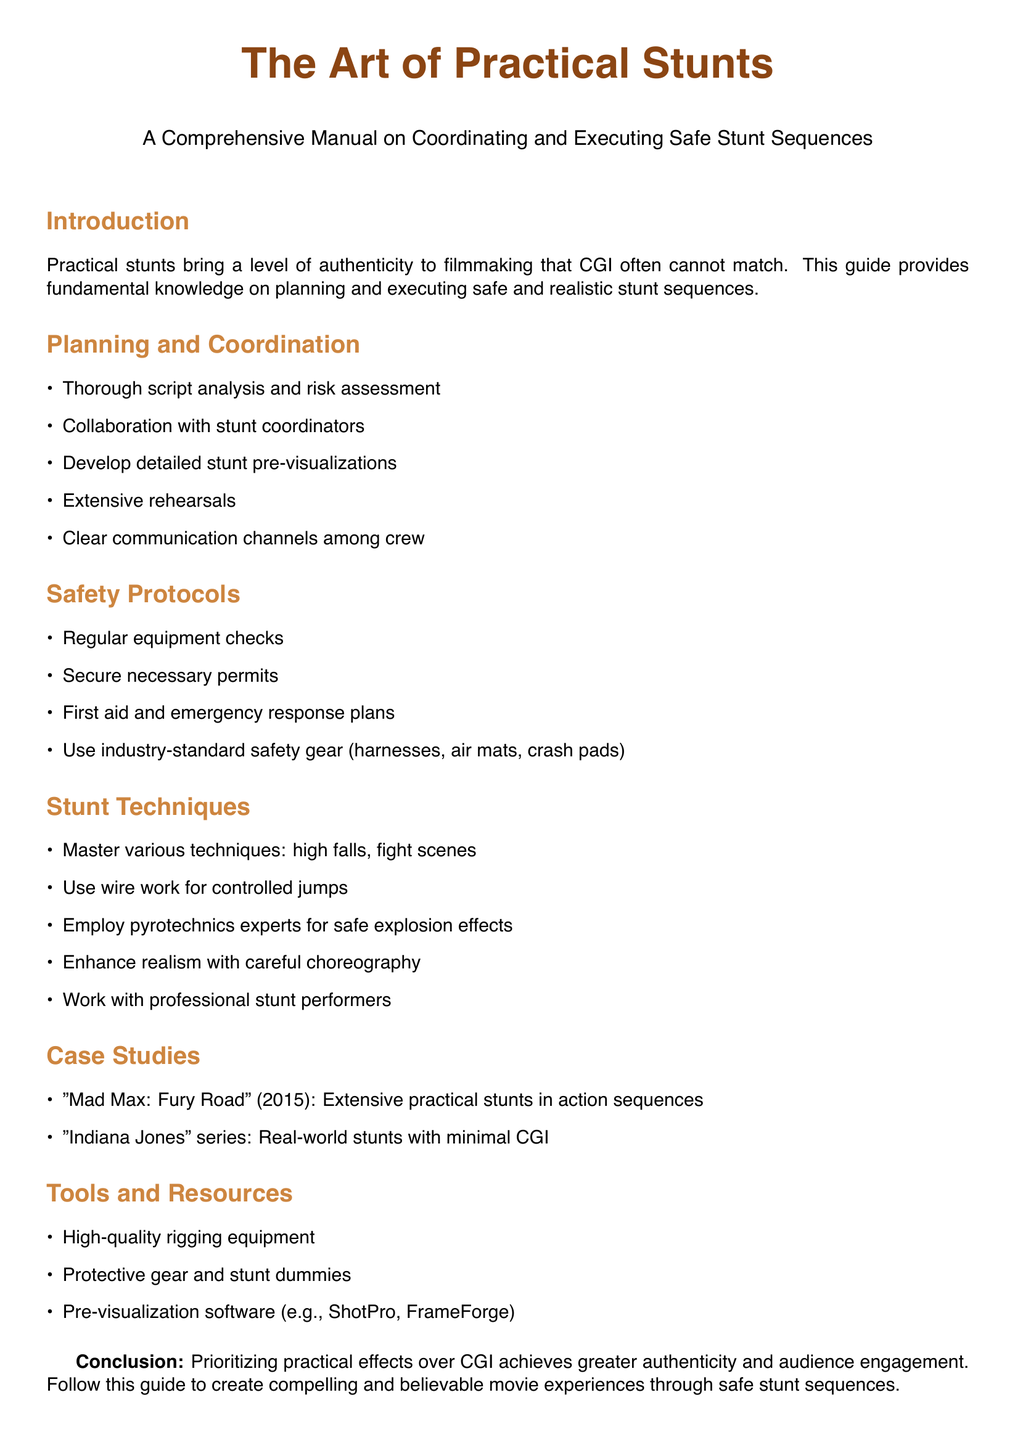what is the main focus of the guide? The guide focuses on practical stunts as a means of achieving authenticity in filmmaking.
Answer: authenticity what are the two notable case studies mentioned? The guide lists "Mad Max: Fury Road" and the "Indiana Jones" series as case studies.
Answer: "Mad Max: Fury Road" and "Indiana Jones" what safety gear is recommended in the guide? The guide recommends industry-standard safety gear including harnesses, air mats, and crash pads.
Answer: harnesses, air mats, crash pads what is the purpose of pre-visualizations in stunt planning? Pre-visualizations help in detailing and planning stunt sequences before execution.
Answer: planning stunt sequences how many main sections are in the guide? The document has five main sections including Introduction and Conclusion.
Answer: five which software is mentioned for pre-visualization? The guide mentions ShotPro and FrameForge as pre-visualization software.
Answer: ShotPro, FrameForge what key aspect does the conclusion emphasize? The conclusion emphasizes the importance of practical effects over CGI for greater audience engagement.
Answer: practical effects over CGI what is essential for safe stunt execution according to the document? Regular equipment checks are essential for safe stunt execution as per the guide.
Answer: Regular equipment checks what is highlighted as a collaboration need in stunt planning? Collaboration with stunt coordinators is highlighted as essential in stunt planning.
Answer: stunt coordinators 